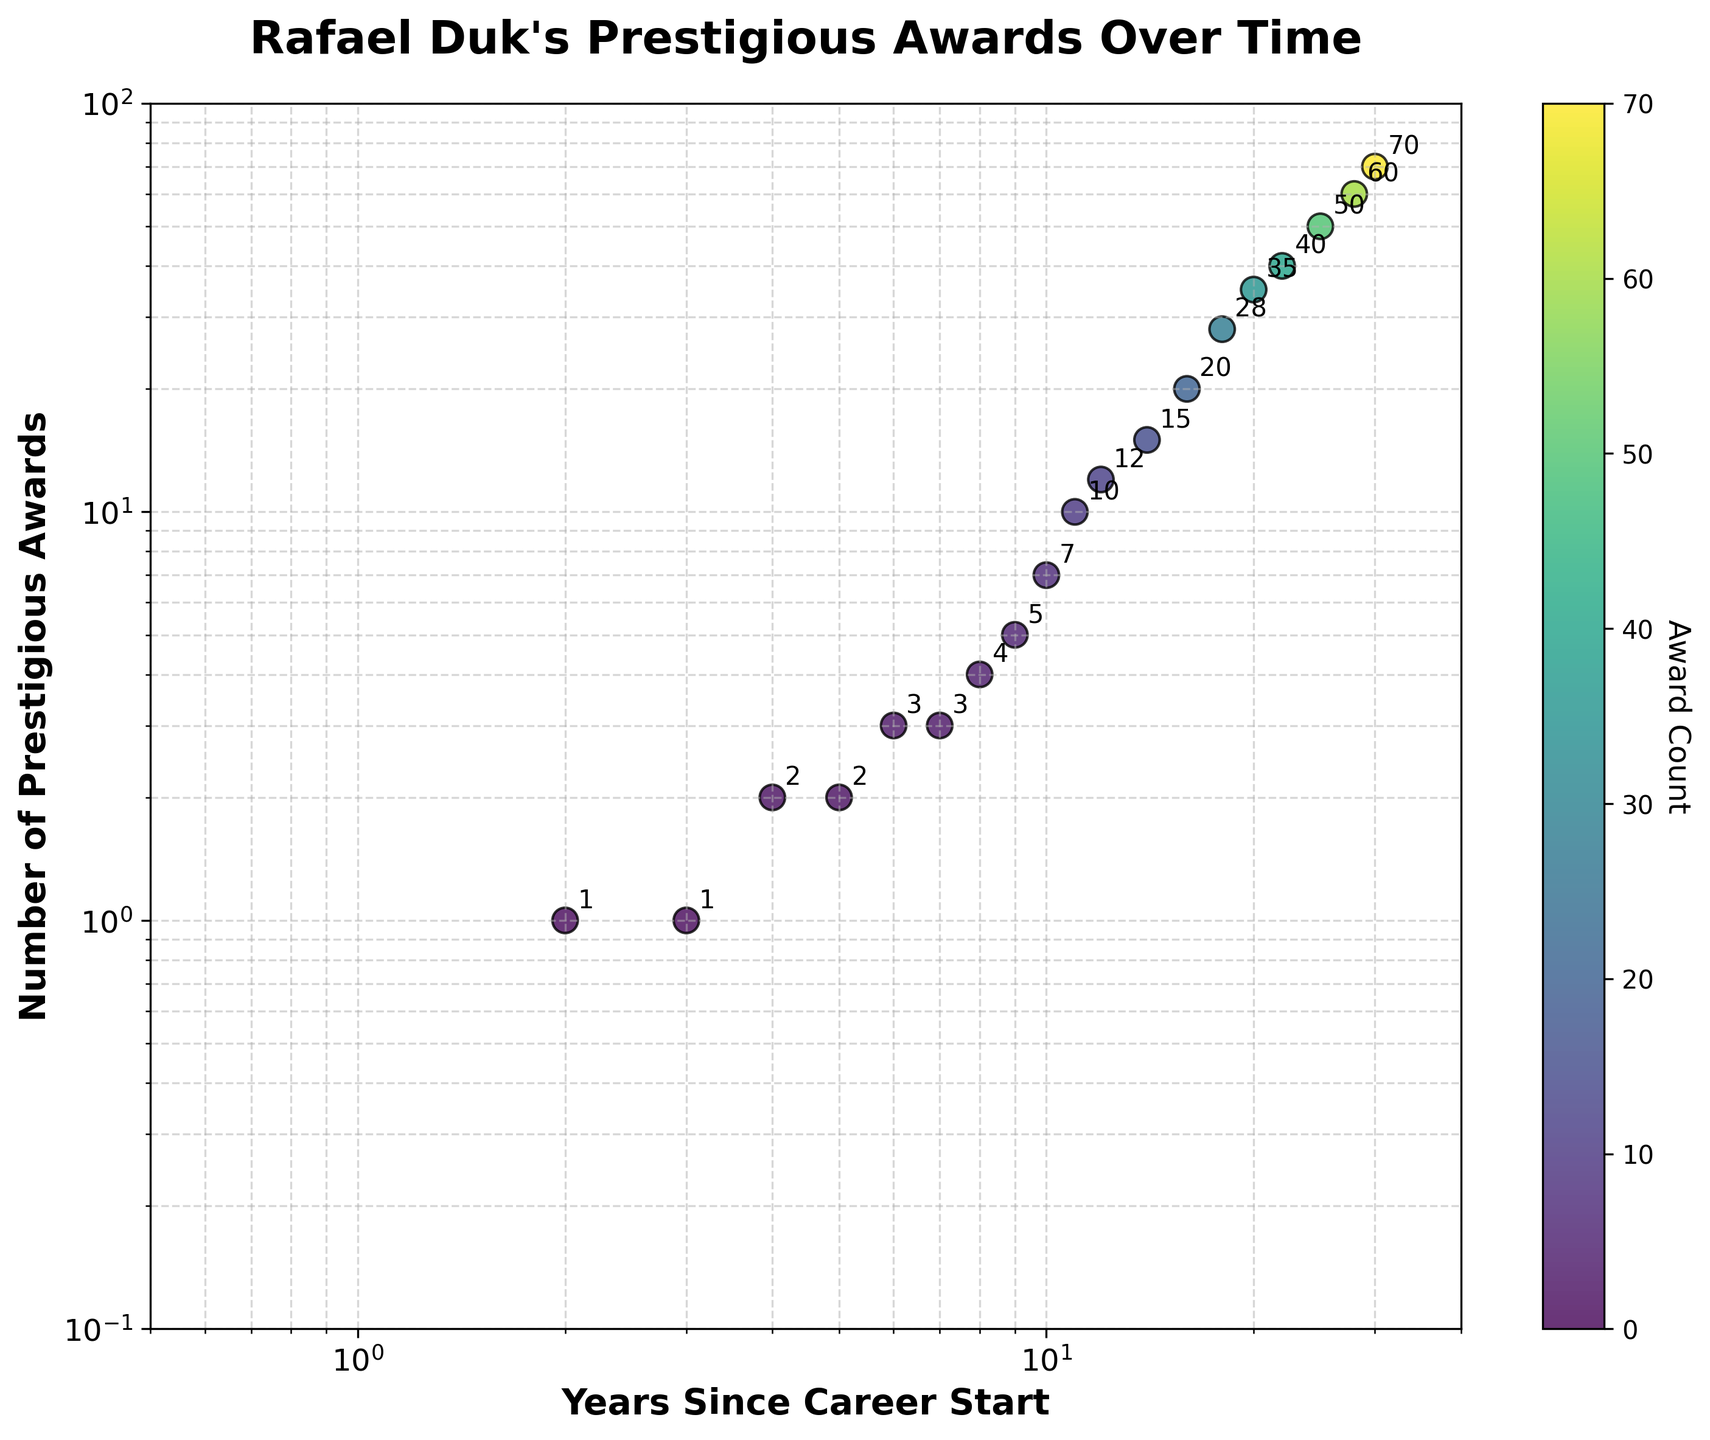What is the title of the scatter plot? The title of the scatter plot is prominently displayed at the top of the figure.
Answer: Rafael Duk's Prestigious Awards Over Time How many years since the start of Rafael Duk's career does the dataset cover? The x-axis shows "Years Since Career Start," and the last data point is at 30 years.
Answer: 30 years How many prestigious awards did Rafael Duk win in the 10th year of his career? Look for the data point corresponding to 10 years on the x-axis and read the y value. The label next to this point indicates the number of awards.
Answer: 7 awards What is the x-axis labeled as? The x-axis label is found below the axis at the bottom of the plot.
Answer: Years Since Career Start What trends can be observed in Rafael Duk's award count over time? By examining the scatter plot's points and their general direction, one can see the trend. The awards generally increase as the years progress.
Answer: Increasing trend How many data points are plotted on the scatter plot? Count the number of individual data points on the scatter plot. Annotations can help verify the count.
Answer: 20 Which year marks the first appearance of a steep increase in the number of awards? Look for the year on the x-axis where the count of awards shows a noticeable jump from the previous year. This can be visually observed.
Answer: 10th year What colors are used to represent the number of awards in the scatter plot? Look at the color scheme on the scatter plot and the color bar on the side. The colormap 'viridis' is commonly used.
Answer: Shades from blue to yellow-green What is the y-axis labeled as? The y-axis label is found to the left of the axis on the plot.
Answer: Number of Prestigious Awards How many awards did Rafael Duk win around 25 years into his career, and how does it compare to the number of awards at the 30-year mark? Look for the data points at 25 years and 30 years on the x-axis, then compare their y values.
Answer: 50 at 25 years and 70 at 30 years What is the increase in the number of awards from year 14 to year 16? Find the y-values for years 14 and 16, and then calculate the difference.
Answer: Increased by 5 awards (20 - 15) What is the general shape of the plot in relation to the log scale axes? Observing the scatter plot under log-log scales, we see if the points follow any trend or curve. The plot appears to show an exponential growth.
Answer: Exponential growth 